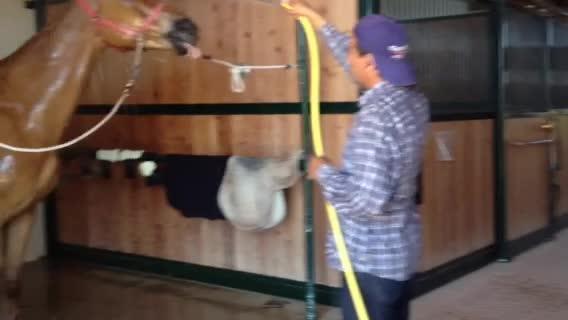How many horses in the photo?
Give a very brief answer. 1. 